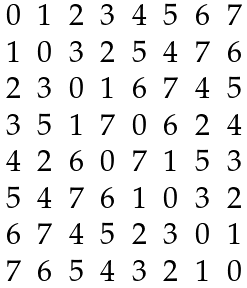<formula> <loc_0><loc_0><loc_500><loc_500>\begin{array} { c c c c c c c c } 0 & 1 & 2 & 3 & 4 & 5 & 6 & 7 \\ 1 & 0 & 3 & 2 & 5 & 4 & 7 & 6 \\ 2 & 3 & 0 & 1 & 6 & 7 & 4 & 5 \\ 3 & 5 & 1 & 7 & 0 & 6 & 2 & 4 \\ 4 & 2 & 6 & 0 & 7 & 1 & 5 & 3 \\ 5 & 4 & 7 & 6 & 1 & 0 & 3 & 2 \\ 6 & 7 & 4 & 5 & 2 & 3 & 0 & 1 \\ 7 & 6 & 5 & 4 & 3 & 2 & 1 & 0 \end{array}</formula> 